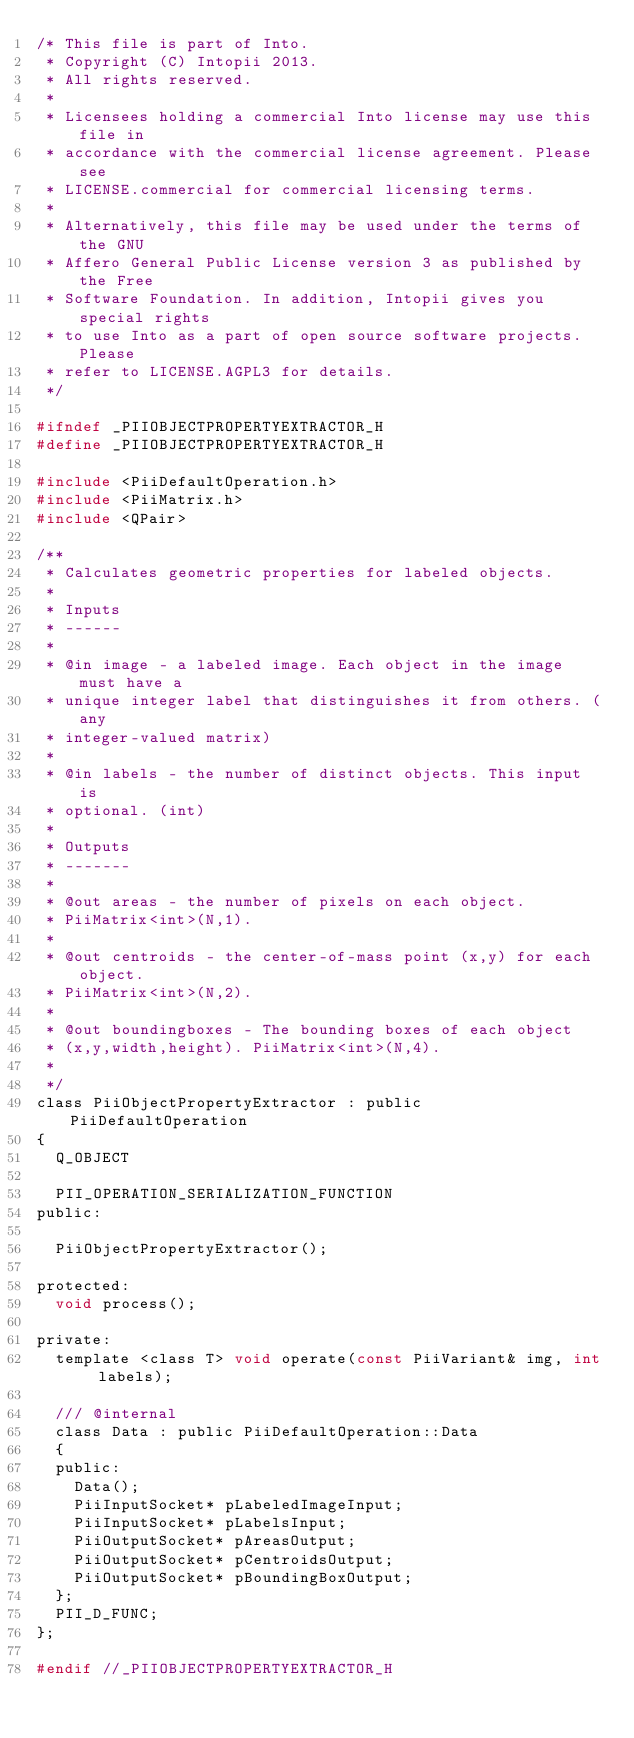Convert code to text. <code><loc_0><loc_0><loc_500><loc_500><_C_>/* This file is part of Into.
 * Copyright (C) Intopii 2013.
 * All rights reserved.
 *
 * Licensees holding a commercial Into license may use this file in
 * accordance with the commercial license agreement. Please see
 * LICENSE.commercial for commercial licensing terms.
 *
 * Alternatively, this file may be used under the terms of the GNU
 * Affero General Public License version 3 as published by the Free
 * Software Foundation. In addition, Intopii gives you special rights
 * to use Into as a part of open source software projects. Please
 * refer to LICENSE.AGPL3 for details.
 */

#ifndef _PIIOBJECTPROPERTYEXTRACTOR_H
#define _PIIOBJECTPROPERTYEXTRACTOR_H

#include <PiiDefaultOperation.h>
#include <PiiMatrix.h>
#include <QPair>

/**
 * Calculates geometric properties for labeled objects.
 *
 * Inputs
 * ------
 *
 * @in image - a labeled image. Each object in the image must have a
 * unique integer label that distinguishes it from others. (any
 * integer-valued matrix)
 *
 * @in labels - the number of distinct objects. This input is
 * optional. (int)
 *
 * Outputs
 * -------
 *
 * @out areas - the number of pixels on each object.
 * PiiMatrix<int>(N,1).
 *
 * @out centroids - the center-of-mass point (x,y) for each object.
 * PiiMatrix<int>(N,2).
 *
 * @out boundingboxes - The bounding boxes of each object
 * (x,y,width,height). PiiMatrix<int>(N,4).
 *
 */
class PiiObjectPropertyExtractor : public PiiDefaultOperation
{
  Q_OBJECT

  PII_OPERATION_SERIALIZATION_FUNCTION
public:

  PiiObjectPropertyExtractor();

protected:
  void process();

private:
  template <class T> void operate(const PiiVariant& img, int labels);

  /// @internal
  class Data : public PiiDefaultOperation::Data
  {
  public:
    Data();
    PiiInputSocket* pLabeledImageInput;
    PiiInputSocket* pLabelsInput;
    PiiOutputSocket* pAreasOutput;
    PiiOutputSocket* pCentroidsOutput;
    PiiOutputSocket* pBoundingBoxOutput;
  };
  PII_D_FUNC;
};

#endif //_PIIOBJECTPROPERTYEXTRACTOR_H
</code> 